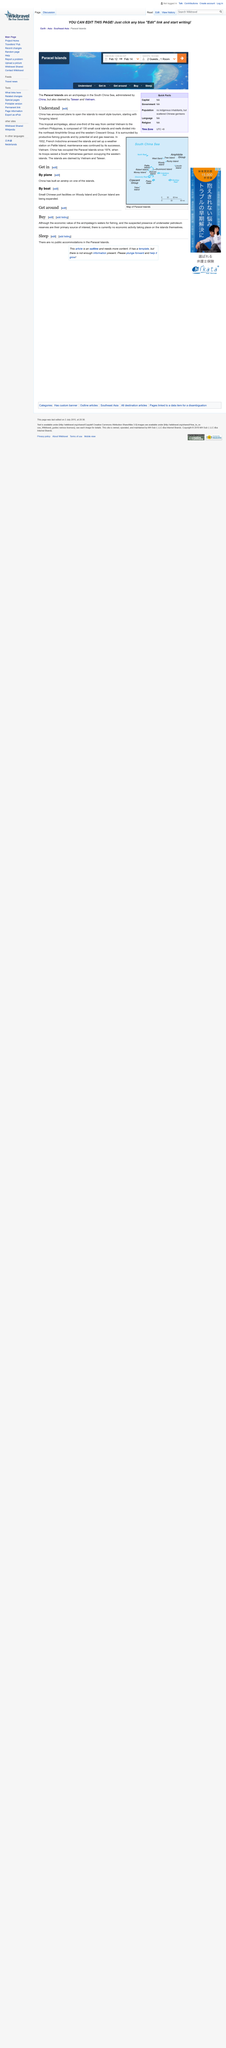Mention a couple of crucial points in this snapshot. Yongxing Island is located in a group of 130 islands. Yongxing Island is part of the Paracel Islands, which is a group of islands that is part of a larger group of islands. In 1974, China began its occupation of the Paracel Islands. 